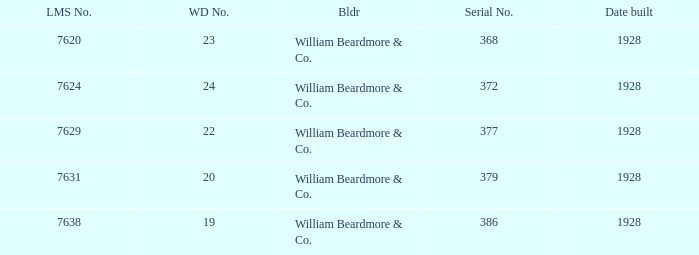Name the total number of serial number for 24 wd no 1.0. 